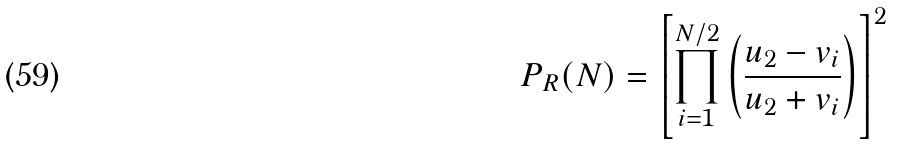<formula> <loc_0><loc_0><loc_500><loc_500>P _ { R } ( N ) = \left [ \prod ^ { N / 2 } _ { i = 1 } \left ( \frac { u _ { 2 } - v _ { i } } { u _ { 2 } + v _ { i } } \right ) \right ] ^ { 2 }</formula> 